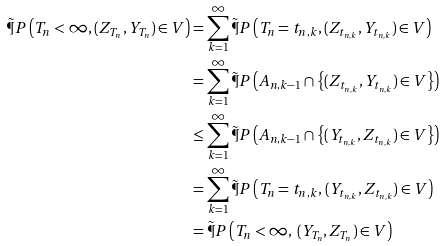<formula> <loc_0><loc_0><loc_500><loc_500>\tilde { \P } P \left ( T _ { n } < \infty , ( Z _ { T _ { n } } , Y _ { T _ { n } } ) \in V \right ) & = \sum _ { k = 1 } ^ { \infty } \tilde { \P } P \left ( T _ { n } = t _ { n , k } , ( Z _ { t _ { n , k } } , Y _ { t _ { n , k } } ) \in V \right ) \\ & = \sum _ { k = 1 } ^ { \infty } \tilde { \P } P \left ( A _ { n , k - 1 } \cap \left \{ ( Z _ { t _ { n , k } } , Y _ { t _ { n , k } } ) \in V \right \} \right ) \\ & \leq \sum _ { k = 1 } ^ { \infty } \tilde { \P } P \left ( A _ { n , k - 1 } \cap \left \{ ( Y _ { t _ { n , k } } , Z _ { t _ { n , k } } ) \in V \right \} \right ) \\ & = \sum _ { k = 1 } ^ { \infty } \tilde { \P } P \left ( T _ { n } = t _ { n , k } , \, ( Y _ { t _ { n , k } } , Z _ { t _ { n , k } } ) \in V \right ) \\ & = \tilde { \P } P \left ( T _ { n } < \infty , \, ( Y _ { T _ { n } } , Z _ { T _ { n } } ) \in V \right )</formula> 